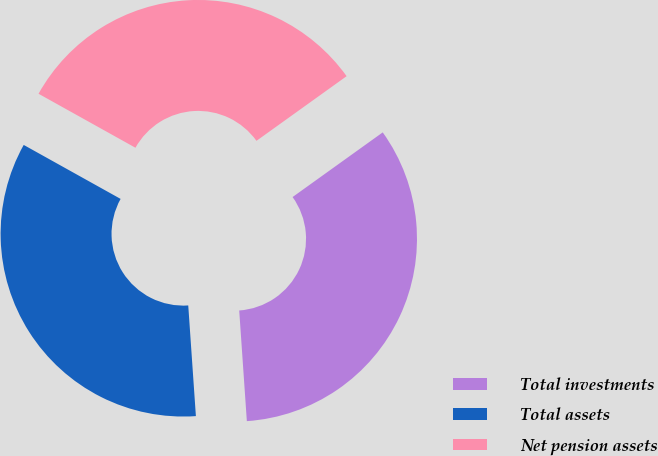Convert chart. <chart><loc_0><loc_0><loc_500><loc_500><pie_chart><fcel>Total investments<fcel>Total assets<fcel>Net pension assets<nl><fcel>33.81%<fcel>34.19%<fcel>32.01%<nl></chart> 